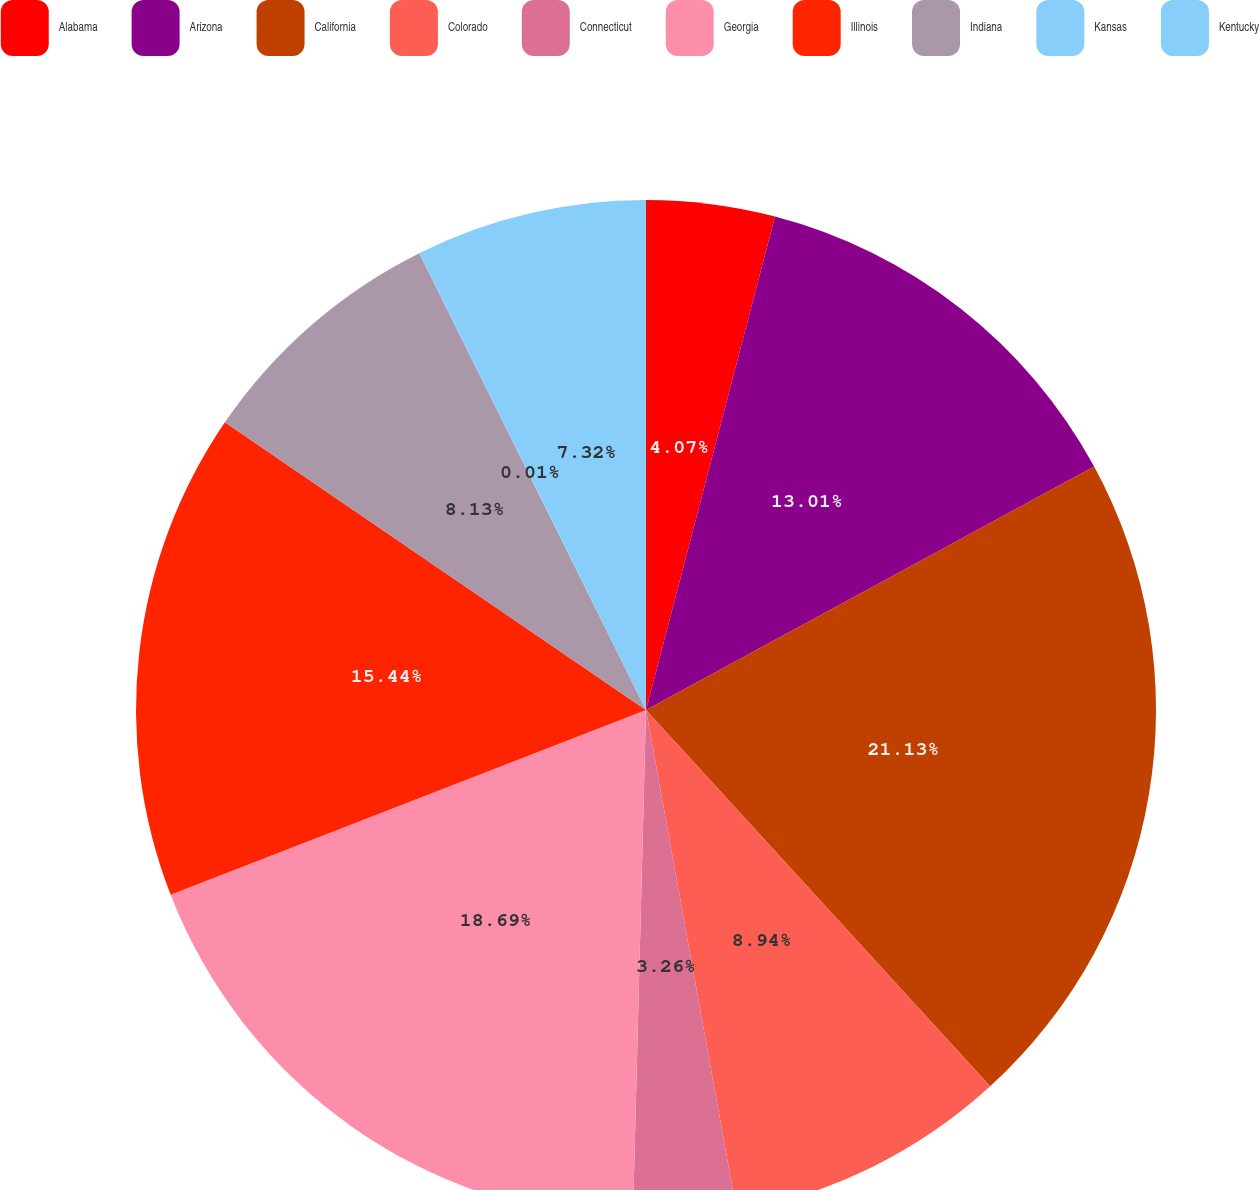Convert chart. <chart><loc_0><loc_0><loc_500><loc_500><pie_chart><fcel>Alabama<fcel>Arizona<fcel>California<fcel>Colorado<fcel>Connecticut<fcel>Georgia<fcel>Illinois<fcel>Indiana<fcel>Kansas<fcel>Kentucky<nl><fcel>4.07%<fcel>13.01%<fcel>21.13%<fcel>8.94%<fcel>3.26%<fcel>18.69%<fcel>15.44%<fcel>8.13%<fcel>0.01%<fcel>7.32%<nl></chart> 